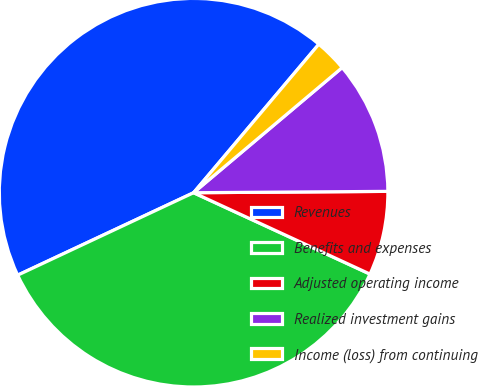Convert chart. <chart><loc_0><loc_0><loc_500><loc_500><pie_chart><fcel>Revenues<fcel>Benefits and expenses<fcel>Adjusted operating income<fcel>Realized investment gains<fcel>Income (loss) from continuing<nl><fcel>43.13%<fcel>36.15%<fcel>6.99%<fcel>11.03%<fcel>2.71%<nl></chart> 